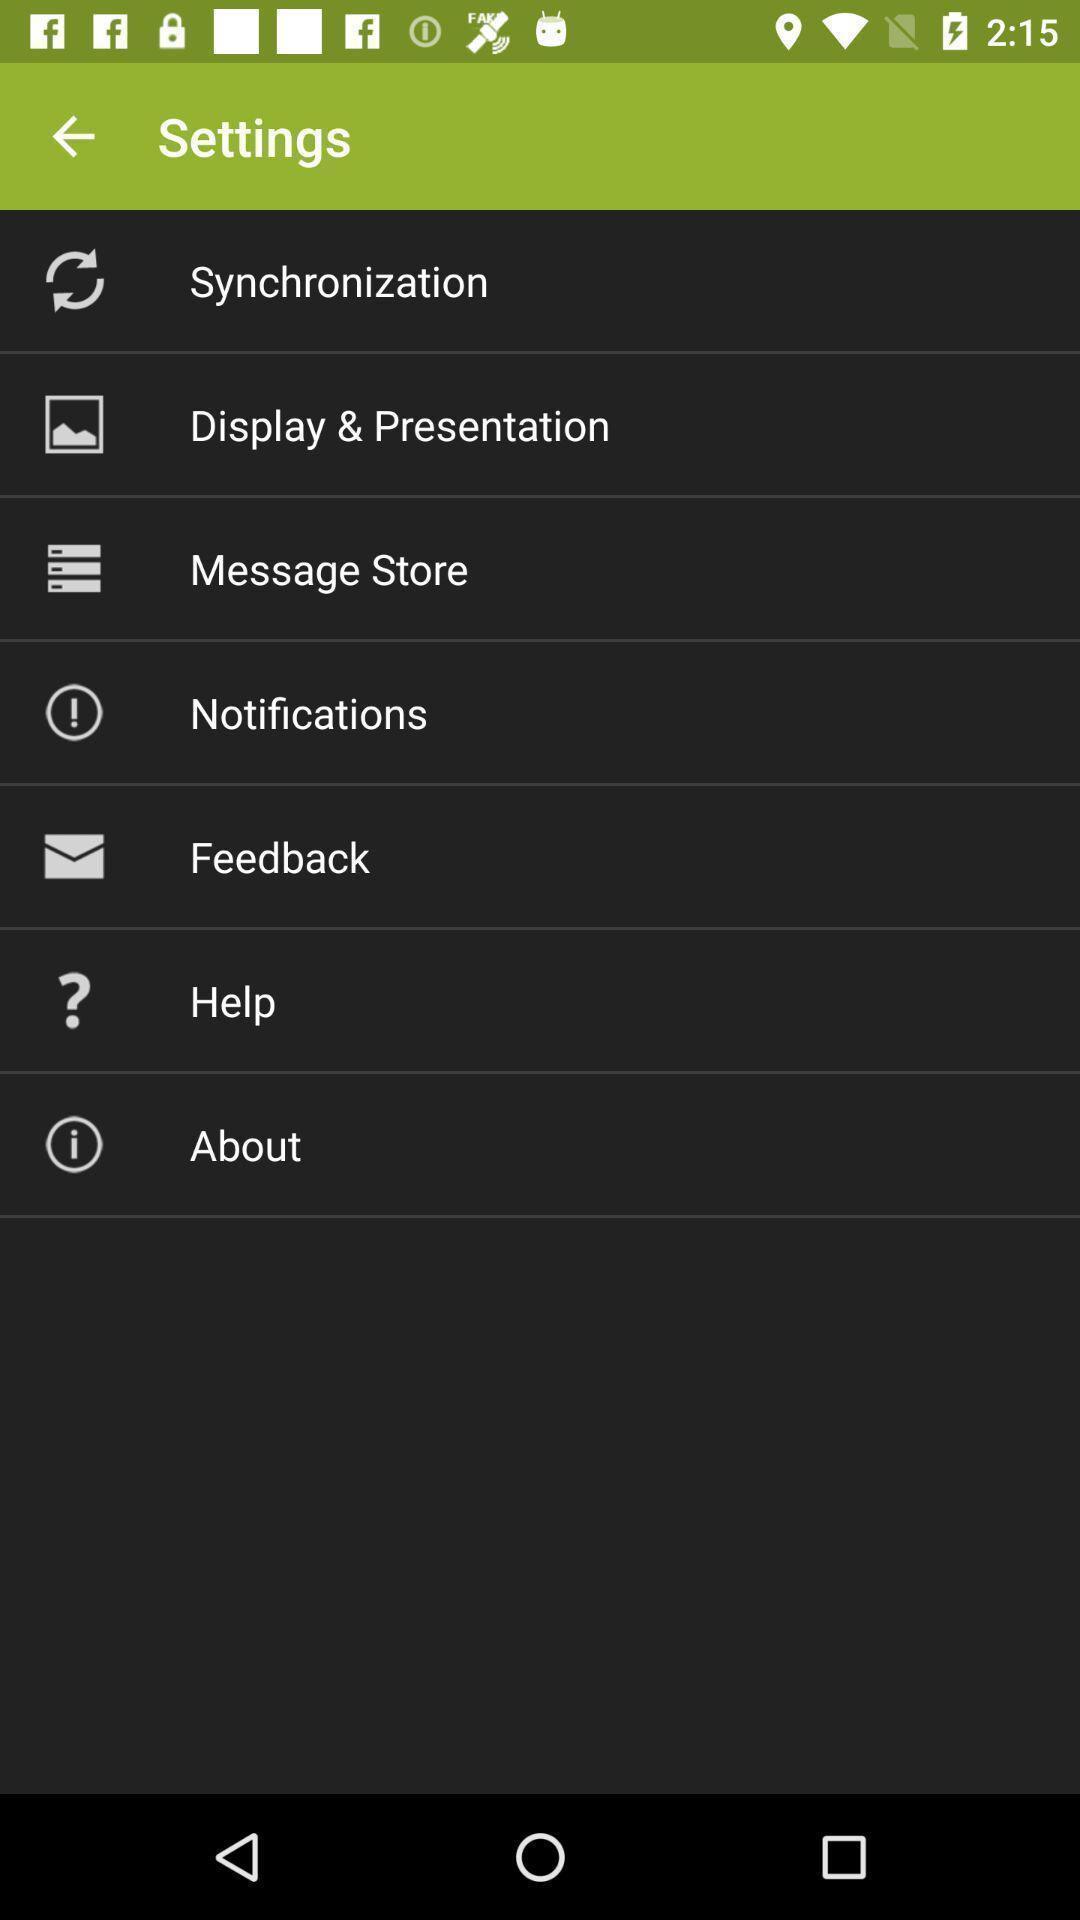Describe the key features of this screenshot. Page showing different options in settings. 